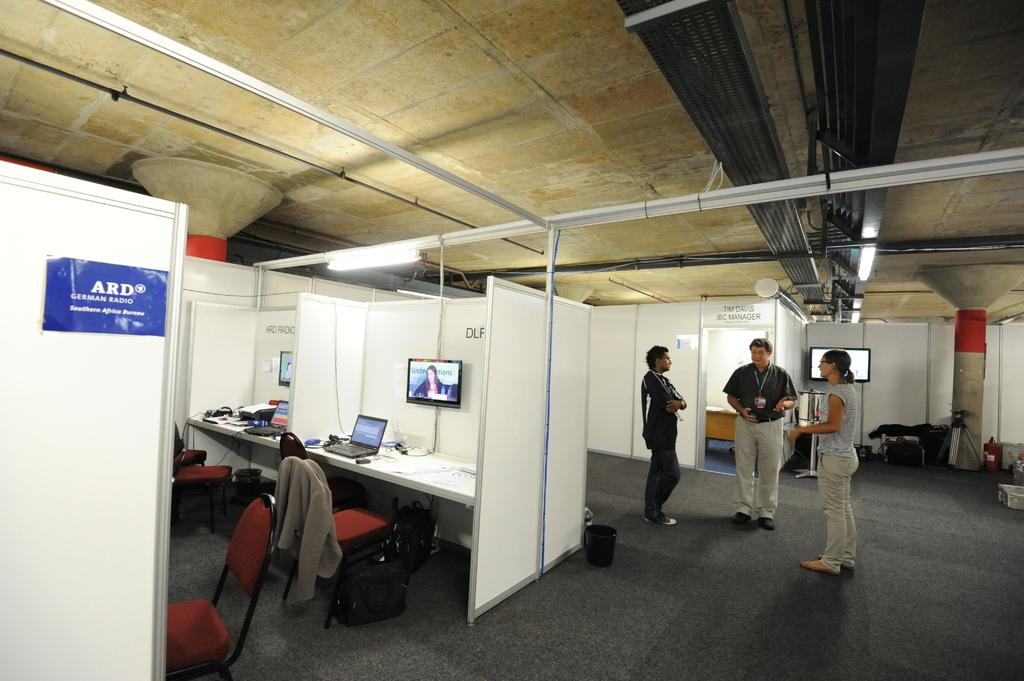How many people are present in the image? There are three people standing in the image. What are the people doing in the image? The people are discussing something. Can you describe any objects in the image besides the people? There is a white color cardboard, a television, a chair, and a bag in the image. What type of dinner is being prepared in the image? There is no indication of dinner preparation in the image. Can you see any ducks in the image? There are no ducks present in the image. 